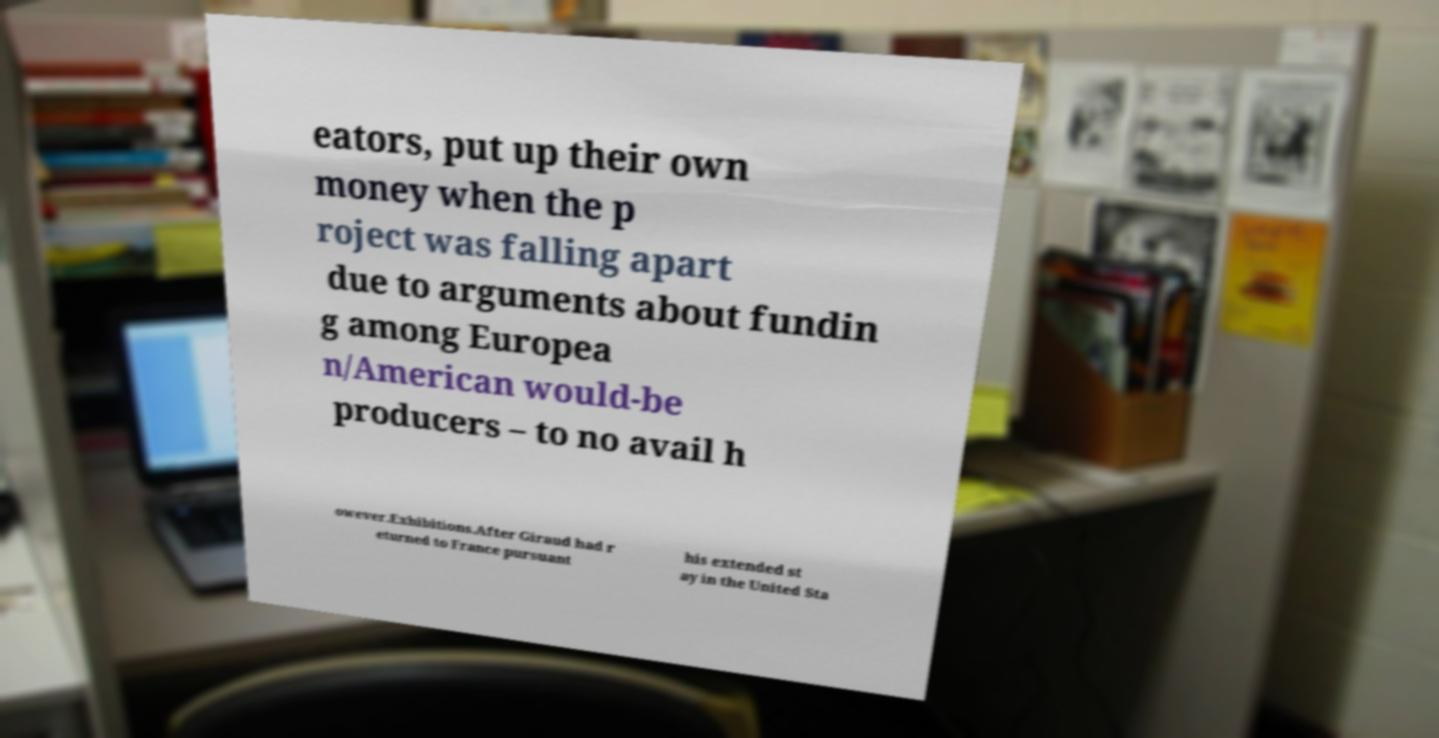I need the written content from this picture converted into text. Can you do that? eators, put up their own money when the p roject was falling apart due to arguments about fundin g among Europea n/American would-be producers – to no avail h owever.Exhibitions.After Giraud had r eturned to France pursuant his extended st ay in the United Sta 